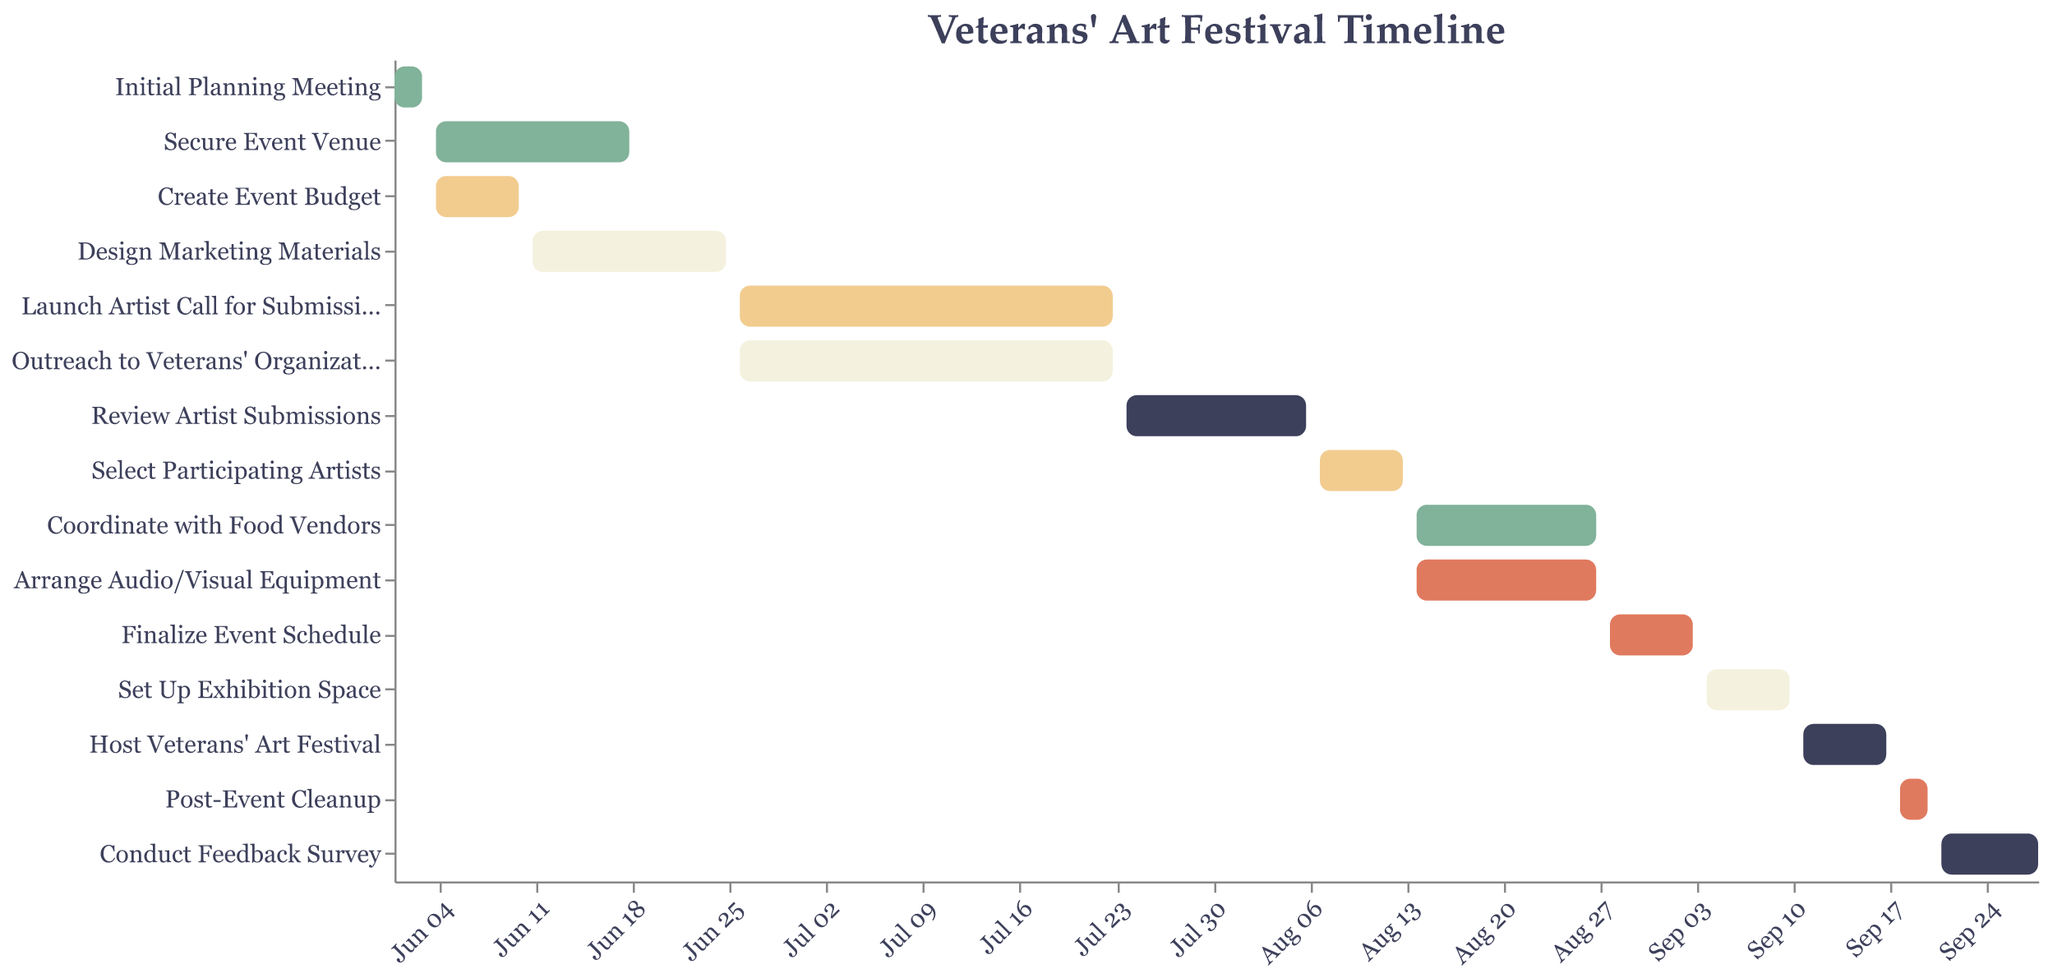What's the title of the Gantt chart? The title of the Gantt chart is shown at the top of the figure and can be read directly.
Answer: Veterans' Art Festival Timeline What task occurs first in the timeline? To determine which task occurs first, look at the task starting earliest on the x-axis.
Answer: Initial Planning Meeting How long is the "Design Marketing Materials" task scheduled to take? To find this, calculate the number of days between the start and end dates given.
Answer: 14 days Which two tasks are occurring simultaneously between June 26 and July 23? Identify overlapping tasks by looking for tasks that share the same start and end dates within the specified range.
Answer: Launch Artist Call for Submissions and Outreach to Veterans' Organizations When is the event venue supposed to be secured by? Look at the end date for the "Secure Event Venue" task to identify when this task should be completed.
Answer: June 18 Which tasks are scheduled to overlap with "Coordinate with Food Vendors"? Examine the timeline to see which tasks fall within or overlap with the start and end dates for "Coordinate with Food Vendors".
Answer: Arrange Audio/Visual Equipment How many tasks are scheduled to be completed by the end of July? Count the number of tasks with an end date on or before July 31.
Answer: 6 tasks Which task has the shortest duration and how long is it? Compare the durations of all tasks by looking at the length between start and end dates, then pick the shortest one.
Answer: Post-Event Cleanup, 3 days When does the post-event cleanup occur? Find the dates associated with the "Post-Event Cleanup" task.
Answer: September 18 - September 20 What is the total duration of the Veterans' Art Festival from the start of the first task to the end of the last task? Calculate the duration from the start date of the earliest task to the end date of the latest task.
Answer: June 1 - September 28 